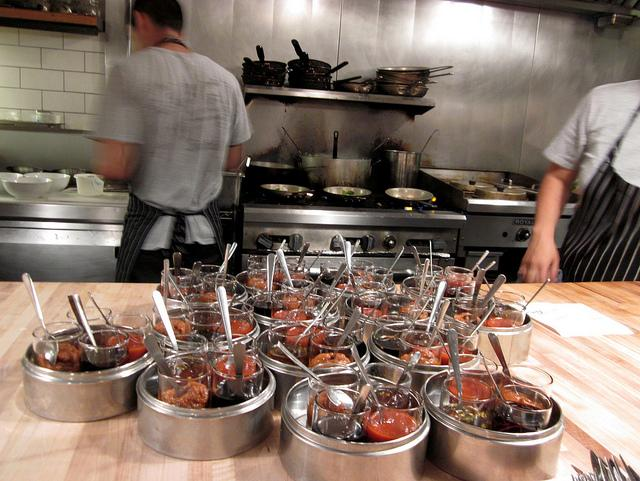Inside silver round large cans what is seen here in profusion? condiments 